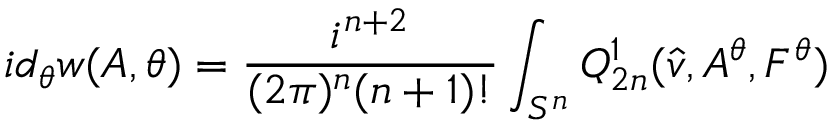<formula> <loc_0><loc_0><loc_500><loc_500>i d _ { \theta } w ( A , \theta ) = \frac { i ^ { n + 2 } } { ( 2 \pi ) ^ { n } ( n + 1 ) ! } \int _ { S ^ { n } } Q _ { 2 n } ^ { 1 } ( \hat { v } , A ^ { \theta } , F ^ { \theta } )</formula> 